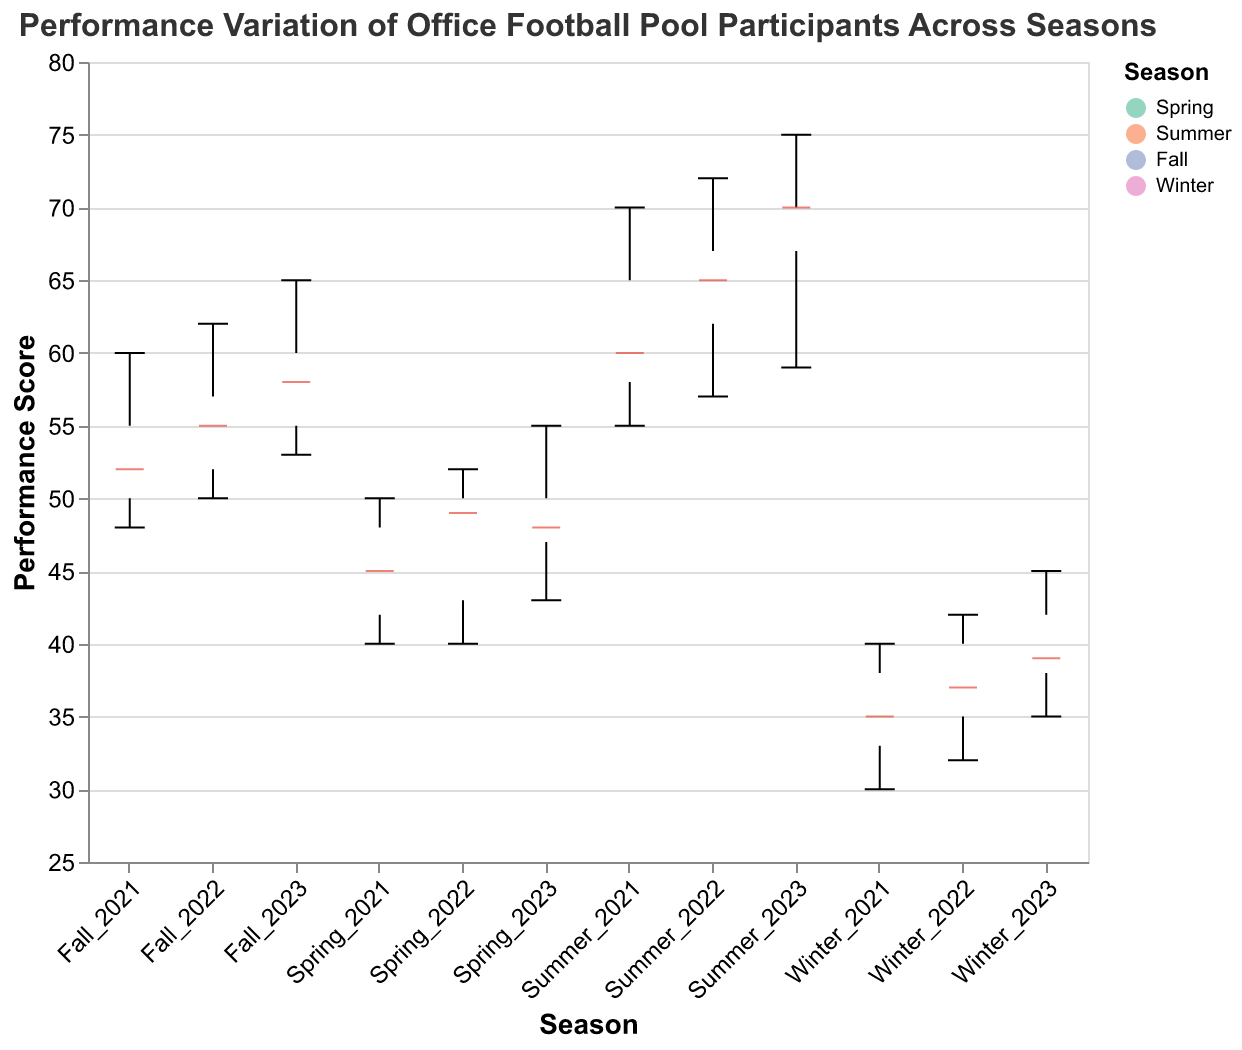What is the title of the figure? The title of the figure is often the most noticeable text and is placed at the top of the plot. It provides a brief but clear description of what the figure represents.
Answer: Performance Variation of Office Football Pool Participants Across Seasons What are the seasons represented in the plot? By examining the x-axis and color legend of the plot, we can identify the different categories or groups represented.
Answer: Spring, Summer, Fall, Winter What is the median performance score in Summer? We look at the central line (which is typically in red) within the boxplot for the Summer season to determine the median value.
Answer: 67 Which season shows the highest variation in performance scores? Variation in a notched box plot can be assessed by the length of the boxes and whiskers. The season with the largest box and whiskers indicates the highest variation.
Answer: Summer How does the median performance score in Winter compare to that in Spring? To compare medians, we look at the central lines of the boxes for Winter and Spring.
Answer: The median in Winter is lower than in Spring What is the range of performance scores in Fall? The range is determined by the minimum and maximum values (whiskers) of the boxplot for Fall.
Answer: 48 to 65 Which season has the smallest interquartile range (IQR)? The IQR is the width of the box in the boxplot. The season with the shortest box has the smallest IQR.
Answer: Winter What are the performance scores for Eve in Spring_2022 and Summer_2023? By examining the data points associated with Eve for these specific seasons, we can identify the performance scores.
Answer: 49 (Spring_2022), 70 (Summer_2023) What is the mean performance score across all seasons? To find the mean, add all performance scores and divide by the number of scores. (Sum of all performance scores) / (Total number of scores) = 2726 / 60 = 45.43
Answer: 45.43 Which season has the most outliers, and what could that indicate? The boxplot marks outliers typically with individual points outside the whiskers. The season with the most individual points outside the whiskers has the most outliers.
Answer: Summer, indicating varied performances potentially influenced by different external factors 